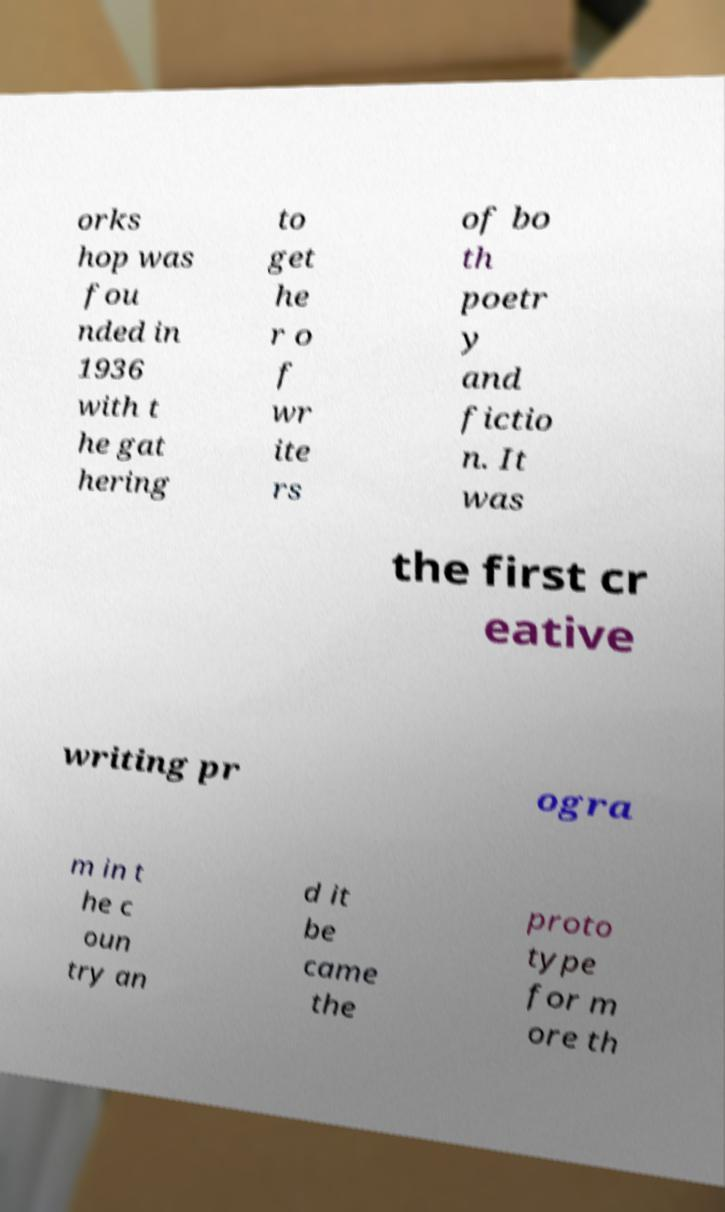Please identify and transcribe the text found in this image. orks hop was fou nded in 1936 with t he gat hering to get he r o f wr ite rs of bo th poetr y and fictio n. It was the first cr eative writing pr ogra m in t he c oun try an d it be came the proto type for m ore th 